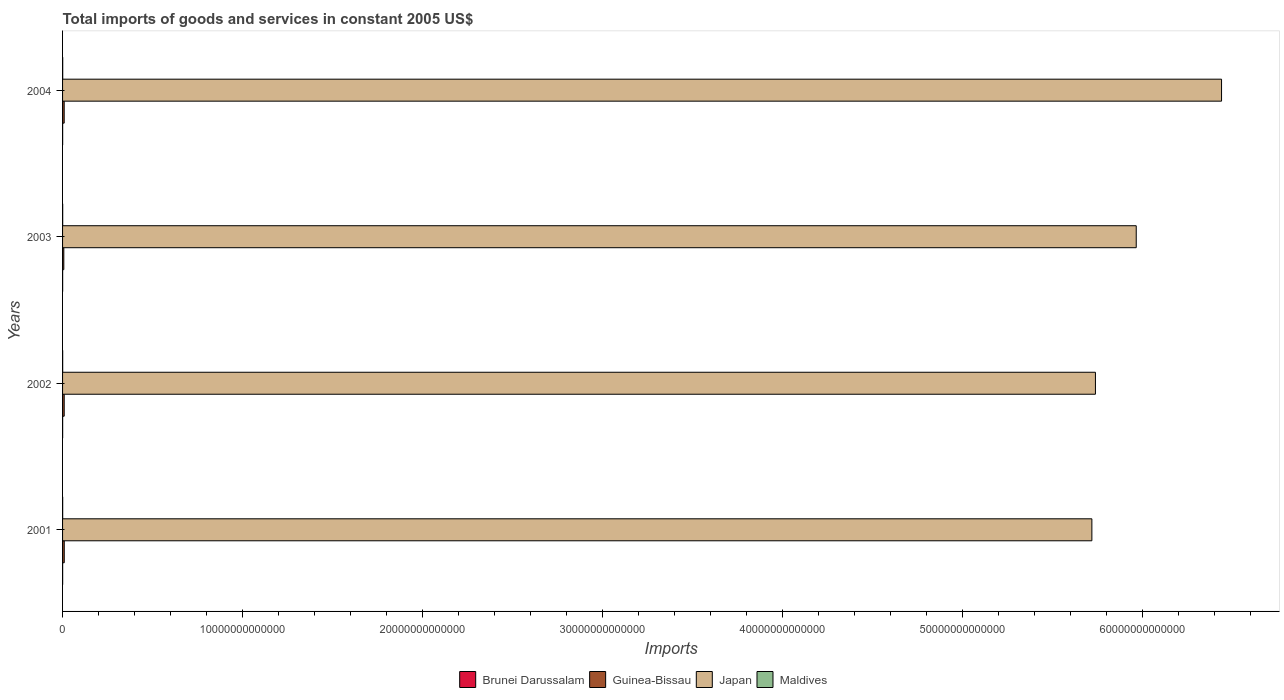Are the number of bars on each tick of the Y-axis equal?
Ensure brevity in your answer.  Yes. How many bars are there on the 1st tick from the top?
Provide a succinct answer. 4. What is the total imports of goods and services in Brunei Darussalam in 2002?
Provide a short and direct response. 4.33e+09. Across all years, what is the maximum total imports of goods and services in Guinea-Bissau?
Make the answer very short. 9.33e+1. Across all years, what is the minimum total imports of goods and services in Japan?
Your answer should be compact. 5.72e+13. In which year was the total imports of goods and services in Brunei Darussalam maximum?
Provide a short and direct response. 2002. In which year was the total imports of goods and services in Japan minimum?
Offer a very short reply. 2001. What is the total total imports of goods and services in Maldives in the graph?
Offer a very short reply. 2.55e+1. What is the difference between the total imports of goods and services in Japan in 2001 and that in 2003?
Offer a very short reply. -2.46e+12. What is the difference between the total imports of goods and services in Maldives in 2001 and the total imports of goods and services in Japan in 2002?
Your answer should be compact. -5.74e+13. What is the average total imports of goods and services in Guinea-Bissau per year?
Your answer should be compact. 8.58e+1. In the year 2003, what is the difference between the total imports of goods and services in Guinea-Bissau and total imports of goods and services in Japan?
Your answer should be very brief. -5.96e+13. In how many years, is the total imports of goods and services in Guinea-Bissau greater than 2000000000000 US$?
Offer a very short reply. 0. What is the ratio of the total imports of goods and services in Maldives in 2001 to that in 2003?
Give a very brief answer. 0.87. Is the total imports of goods and services in Maldives in 2001 less than that in 2002?
Your answer should be compact. Yes. Is the difference between the total imports of goods and services in Guinea-Bissau in 2002 and 2003 greater than the difference between the total imports of goods and services in Japan in 2002 and 2003?
Make the answer very short. Yes. What is the difference between the highest and the second highest total imports of goods and services in Japan?
Your answer should be compact. 4.74e+12. What is the difference between the highest and the lowest total imports of goods and services in Brunei Darussalam?
Offer a terse response. 5.10e+08. Is the sum of the total imports of goods and services in Brunei Darussalam in 2001 and 2004 greater than the maximum total imports of goods and services in Maldives across all years?
Give a very brief answer. No. What does the 3rd bar from the top in 2004 represents?
Keep it short and to the point. Guinea-Bissau. What does the 4th bar from the bottom in 2004 represents?
Make the answer very short. Maldives. Is it the case that in every year, the sum of the total imports of goods and services in Japan and total imports of goods and services in Guinea-Bissau is greater than the total imports of goods and services in Maldives?
Offer a terse response. Yes. How many bars are there?
Offer a very short reply. 16. Are all the bars in the graph horizontal?
Your answer should be compact. Yes. How many years are there in the graph?
Make the answer very short. 4. What is the difference between two consecutive major ticks on the X-axis?
Provide a succinct answer. 1.00e+13. Does the graph contain any zero values?
Provide a succinct answer. No. How are the legend labels stacked?
Give a very brief answer. Horizontal. What is the title of the graph?
Give a very brief answer. Total imports of goods and services in constant 2005 US$. Does "Cyprus" appear as one of the legend labels in the graph?
Your answer should be very brief. No. What is the label or title of the X-axis?
Ensure brevity in your answer.  Imports. What is the label or title of the Y-axis?
Offer a very short reply. Years. What is the Imports in Brunei Darussalam in 2001?
Your answer should be very brief. 3.82e+09. What is the Imports of Guinea-Bissau in 2001?
Ensure brevity in your answer.  9.33e+1. What is the Imports in Japan in 2001?
Ensure brevity in your answer.  5.72e+13. What is the Imports of Maldives in 2001?
Your answer should be very brief. 5.53e+09. What is the Imports of Brunei Darussalam in 2002?
Your answer should be compact. 4.33e+09. What is the Imports of Guinea-Bissau in 2002?
Offer a terse response. 9.06e+1. What is the Imports in Japan in 2002?
Ensure brevity in your answer.  5.74e+13. What is the Imports in Maldives in 2002?
Provide a short and direct response. 5.57e+09. What is the Imports in Brunei Darussalam in 2003?
Ensure brevity in your answer.  3.98e+09. What is the Imports of Guinea-Bissau in 2003?
Provide a succinct answer. 6.93e+1. What is the Imports of Japan in 2003?
Your answer should be compact. 5.96e+13. What is the Imports of Maldives in 2003?
Your response must be concise. 6.38e+09. What is the Imports of Brunei Darussalam in 2004?
Offer a very short reply. 3.86e+09. What is the Imports in Guinea-Bissau in 2004?
Your response must be concise. 9.00e+1. What is the Imports in Japan in 2004?
Make the answer very short. 6.44e+13. What is the Imports of Maldives in 2004?
Ensure brevity in your answer.  7.99e+09. Across all years, what is the maximum Imports of Brunei Darussalam?
Offer a very short reply. 4.33e+09. Across all years, what is the maximum Imports of Guinea-Bissau?
Keep it short and to the point. 9.33e+1. Across all years, what is the maximum Imports of Japan?
Your response must be concise. 6.44e+13. Across all years, what is the maximum Imports in Maldives?
Offer a very short reply. 7.99e+09. Across all years, what is the minimum Imports of Brunei Darussalam?
Provide a short and direct response. 3.82e+09. Across all years, what is the minimum Imports in Guinea-Bissau?
Make the answer very short. 6.93e+1. Across all years, what is the minimum Imports of Japan?
Offer a very short reply. 5.72e+13. Across all years, what is the minimum Imports of Maldives?
Give a very brief answer. 5.53e+09. What is the total Imports in Brunei Darussalam in the graph?
Offer a terse response. 1.60e+1. What is the total Imports in Guinea-Bissau in the graph?
Your response must be concise. 3.43e+11. What is the total Imports of Japan in the graph?
Provide a succinct answer. 2.39e+14. What is the total Imports in Maldives in the graph?
Keep it short and to the point. 2.55e+1. What is the difference between the Imports of Brunei Darussalam in 2001 and that in 2002?
Offer a very short reply. -5.10e+08. What is the difference between the Imports in Guinea-Bissau in 2001 and that in 2002?
Your answer should be compact. 2.73e+09. What is the difference between the Imports in Japan in 2001 and that in 2002?
Offer a terse response. -1.98e+11. What is the difference between the Imports in Maldives in 2001 and that in 2002?
Provide a succinct answer. -3.24e+07. What is the difference between the Imports in Brunei Darussalam in 2001 and that in 2003?
Provide a short and direct response. -1.60e+08. What is the difference between the Imports of Guinea-Bissau in 2001 and that in 2003?
Your answer should be compact. 2.40e+1. What is the difference between the Imports in Japan in 2001 and that in 2003?
Your answer should be very brief. -2.46e+12. What is the difference between the Imports of Maldives in 2001 and that in 2003?
Make the answer very short. -8.45e+08. What is the difference between the Imports of Brunei Darussalam in 2001 and that in 2004?
Make the answer very short. -3.53e+07. What is the difference between the Imports of Guinea-Bissau in 2001 and that in 2004?
Your response must be concise. 3.27e+09. What is the difference between the Imports of Japan in 2001 and that in 2004?
Ensure brevity in your answer.  -7.20e+12. What is the difference between the Imports of Maldives in 2001 and that in 2004?
Your answer should be compact. -2.45e+09. What is the difference between the Imports in Brunei Darussalam in 2002 and that in 2003?
Provide a succinct answer. 3.50e+08. What is the difference between the Imports of Guinea-Bissau in 2002 and that in 2003?
Your response must be concise. 2.13e+1. What is the difference between the Imports of Japan in 2002 and that in 2003?
Give a very brief answer. -2.27e+12. What is the difference between the Imports in Maldives in 2002 and that in 2003?
Offer a very short reply. -8.12e+08. What is the difference between the Imports in Brunei Darussalam in 2002 and that in 2004?
Give a very brief answer. 4.75e+08. What is the difference between the Imports in Guinea-Bissau in 2002 and that in 2004?
Your response must be concise. 5.35e+08. What is the difference between the Imports in Japan in 2002 and that in 2004?
Give a very brief answer. -7.01e+12. What is the difference between the Imports in Maldives in 2002 and that in 2004?
Provide a succinct answer. -2.42e+09. What is the difference between the Imports of Brunei Darussalam in 2003 and that in 2004?
Your response must be concise. 1.25e+08. What is the difference between the Imports of Guinea-Bissau in 2003 and that in 2004?
Make the answer very short. -2.08e+1. What is the difference between the Imports in Japan in 2003 and that in 2004?
Provide a succinct answer. -4.74e+12. What is the difference between the Imports in Maldives in 2003 and that in 2004?
Your response must be concise. -1.61e+09. What is the difference between the Imports of Brunei Darussalam in 2001 and the Imports of Guinea-Bissau in 2002?
Give a very brief answer. -8.67e+1. What is the difference between the Imports of Brunei Darussalam in 2001 and the Imports of Japan in 2002?
Keep it short and to the point. -5.74e+13. What is the difference between the Imports of Brunei Darussalam in 2001 and the Imports of Maldives in 2002?
Ensure brevity in your answer.  -1.74e+09. What is the difference between the Imports in Guinea-Bissau in 2001 and the Imports in Japan in 2002?
Give a very brief answer. -5.73e+13. What is the difference between the Imports of Guinea-Bissau in 2001 and the Imports of Maldives in 2002?
Provide a succinct answer. 8.77e+1. What is the difference between the Imports of Japan in 2001 and the Imports of Maldives in 2002?
Provide a succinct answer. 5.72e+13. What is the difference between the Imports in Brunei Darussalam in 2001 and the Imports in Guinea-Bissau in 2003?
Your answer should be compact. -6.54e+1. What is the difference between the Imports of Brunei Darussalam in 2001 and the Imports of Japan in 2003?
Your answer should be compact. -5.96e+13. What is the difference between the Imports of Brunei Darussalam in 2001 and the Imports of Maldives in 2003?
Make the answer very short. -2.56e+09. What is the difference between the Imports of Guinea-Bissau in 2001 and the Imports of Japan in 2003?
Your answer should be compact. -5.96e+13. What is the difference between the Imports of Guinea-Bissau in 2001 and the Imports of Maldives in 2003?
Give a very brief answer. 8.69e+1. What is the difference between the Imports in Japan in 2001 and the Imports in Maldives in 2003?
Your response must be concise. 5.72e+13. What is the difference between the Imports in Brunei Darussalam in 2001 and the Imports in Guinea-Bissau in 2004?
Your response must be concise. -8.62e+1. What is the difference between the Imports of Brunei Darussalam in 2001 and the Imports of Japan in 2004?
Ensure brevity in your answer.  -6.44e+13. What is the difference between the Imports of Brunei Darussalam in 2001 and the Imports of Maldives in 2004?
Offer a very short reply. -4.16e+09. What is the difference between the Imports of Guinea-Bissau in 2001 and the Imports of Japan in 2004?
Your answer should be compact. -6.43e+13. What is the difference between the Imports of Guinea-Bissau in 2001 and the Imports of Maldives in 2004?
Make the answer very short. 8.53e+1. What is the difference between the Imports in Japan in 2001 and the Imports in Maldives in 2004?
Your answer should be compact. 5.72e+13. What is the difference between the Imports in Brunei Darussalam in 2002 and the Imports in Guinea-Bissau in 2003?
Provide a succinct answer. -6.49e+1. What is the difference between the Imports in Brunei Darussalam in 2002 and the Imports in Japan in 2003?
Provide a short and direct response. -5.96e+13. What is the difference between the Imports in Brunei Darussalam in 2002 and the Imports in Maldives in 2003?
Your answer should be very brief. -2.05e+09. What is the difference between the Imports of Guinea-Bissau in 2002 and the Imports of Japan in 2003?
Keep it short and to the point. -5.96e+13. What is the difference between the Imports of Guinea-Bissau in 2002 and the Imports of Maldives in 2003?
Keep it short and to the point. 8.42e+1. What is the difference between the Imports of Japan in 2002 and the Imports of Maldives in 2003?
Provide a succinct answer. 5.74e+13. What is the difference between the Imports of Brunei Darussalam in 2002 and the Imports of Guinea-Bissau in 2004?
Your answer should be compact. -8.57e+1. What is the difference between the Imports of Brunei Darussalam in 2002 and the Imports of Japan in 2004?
Your response must be concise. -6.44e+13. What is the difference between the Imports of Brunei Darussalam in 2002 and the Imports of Maldives in 2004?
Offer a very short reply. -3.65e+09. What is the difference between the Imports of Guinea-Bissau in 2002 and the Imports of Japan in 2004?
Ensure brevity in your answer.  -6.43e+13. What is the difference between the Imports of Guinea-Bissau in 2002 and the Imports of Maldives in 2004?
Give a very brief answer. 8.26e+1. What is the difference between the Imports of Japan in 2002 and the Imports of Maldives in 2004?
Offer a terse response. 5.74e+13. What is the difference between the Imports in Brunei Darussalam in 2003 and the Imports in Guinea-Bissau in 2004?
Make the answer very short. -8.60e+1. What is the difference between the Imports of Brunei Darussalam in 2003 and the Imports of Japan in 2004?
Give a very brief answer. -6.44e+13. What is the difference between the Imports in Brunei Darussalam in 2003 and the Imports in Maldives in 2004?
Offer a terse response. -4.00e+09. What is the difference between the Imports in Guinea-Bissau in 2003 and the Imports in Japan in 2004?
Provide a succinct answer. -6.43e+13. What is the difference between the Imports in Guinea-Bissau in 2003 and the Imports in Maldives in 2004?
Offer a terse response. 6.13e+1. What is the difference between the Imports in Japan in 2003 and the Imports in Maldives in 2004?
Offer a terse response. 5.96e+13. What is the average Imports of Brunei Darussalam per year?
Make the answer very short. 4.00e+09. What is the average Imports in Guinea-Bissau per year?
Your answer should be compact. 8.58e+1. What is the average Imports in Japan per year?
Ensure brevity in your answer.  5.96e+13. What is the average Imports of Maldives per year?
Your response must be concise. 6.37e+09. In the year 2001, what is the difference between the Imports in Brunei Darussalam and Imports in Guinea-Bissau?
Keep it short and to the point. -8.95e+1. In the year 2001, what is the difference between the Imports of Brunei Darussalam and Imports of Japan?
Provide a short and direct response. -5.72e+13. In the year 2001, what is the difference between the Imports of Brunei Darussalam and Imports of Maldives?
Offer a very short reply. -1.71e+09. In the year 2001, what is the difference between the Imports in Guinea-Bissau and Imports in Japan?
Your response must be concise. -5.71e+13. In the year 2001, what is the difference between the Imports of Guinea-Bissau and Imports of Maldives?
Offer a very short reply. 8.77e+1. In the year 2001, what is the difference between the Imports in Japan and Imports in Maldives?
Make the answer very short. 5.72e+13. In the year 2002, what is the difference between the Imports of Brunei Darussalam and Imports of Guinea-Bissau?
Your response must be concise. -8.62e+1. In the year 2002, what is the difference between the Imports of Brunei Darussalam and Imports of Japan?
Provide a short and direct response. -5.74e+13. In the year 2002, what is the difference between the Imports of Brunei Darussalam and Imports of Maldives?
Provide a succinct answer. -1.23e+09. In the year 2002, what is the difference between the Imports of Guinea-Bissau and Imports of Japan?
Make the answer very short. -5.73e+13. In the year 2002, what is the difference between the Imports in Guinea-Bissau and Imports in Maldives?
Offer a very short reply. 8.50e+1. In the year 2002, what is the difference between the Imports in Japan and Imports in Maldives?
Your answer should be compact. 5.74e+13. In the year 2003, what is the difference between the Imports in Brunei Darussalam and Imports in Guinea-Bissau?
Make the answer very short. -6.53e+1. In the year 2003, what is the difference between the Imports of Brunei Darussalam and Imports of Japan?
Offer a very short reply. -5.96e+13. In the year 2003, what is the difference between the Imports of Brunei Darussalam and Imports of Maldives?
Your answer should be very brief. -2.39e+09. In the year 2003, what is the difference between the Imports of Guinea-Bissau and Imports of Japan?
Your answer should be compact. -5.96e+13. In the year 2003, what is the difference between the Imports in Guinea-Bissau and Imports in Maldives?
Offer a terse response. 6.29e+1. In the year 2003, what is the difference between the Imports of Japan and Imports of Maldives?
Keep it short and to the point. 5.96e+13. In the year 2004, what is the difference between the Imports in Brunei Darussalam and Imports in Guinea-Bissau?
Keep it short and to the point. -8.62e+1. In the year 2004, what is the difference between the Imports in Brunei Darussalam and Imports in Japan?
Your answer should be very brief. -6.44e+13. In the year 2004, what is the difference between the Imports of Brunei Darussalam and Imports of Maldives?
Keep it short and to the point. -4.13e+09. In the year 2004, what is the difference between the Imports in Guinea-Bissau and Imports in Japan?
Your answer should be compact. -6.43e+13. In the year 2004, what is the difference between the Imports in Guinea-Bissau and Imports in Maldives?
Your answer should be very brief. 8.20e+1. In the year 2004, what is the difference between the Imports of Japan and Imports of Maldives?
Your answer should be compact. 6.44e+13. What is the ratio of the Imports of Brunei Darussalam in 2001 to that in 2002?
Your response must be concise. 0.88. What is the ratio of the Imports in Guinea-Bissau in 2001 to that in 2002?
Your response must be concise. 1.03. What is the ratio of the Imports of Brunei Darussalam in 2001 to that in 2003?
Keep it short and to the point. 0.96. What is the ratio of the Imports in Guinea-Bissau in 2001 to that in 2003?
Your response must be concise. 1.35. What is the ratio of the Imports in Japan in 2001 to that in 2003?
Your answer should be compact. 0.96. What is the ratio of the Imports of Maldives in 2001 to that in 2003?
Ensure brevity in your answer.  0.87. What is the ratio of the Imports in Brunei Darussalam in 2001 to that in 2004?
Ensure brevity in your answer.  0.99. What is the ratio of the Imports in Guinea-Bissau in 2001 to that in 2004?
Your answer should be compact. 1.04. What is the ratio of the Imports of Japan in 2001 to that in 2004?
Ensure brevity in your answer.  0.89. What is the ratio of the Imports of Maldives in 2001 to that in 2004?
Keep it short and to the point. 0.69. What is the ratio of the Imports in Brunei Darussalam in 2002 to that in 2003?
Offer a terse response. 1.09. What is the ratio of the Imports of Guinea-Bissau in 2002 to that in 2003?
Provide a short and direct response. 1.31. What is the ratio of the Imports in Japan in 2002 to that in 2003?
Give a very brief answer. 0.96. What is the ratio of the Imports of Maldives in 2002 to that in 2003?
Provide a short and direct response. 0.87. What is the ratio of the Imports in Brunei Darussalam in 2002 to that in 2004?
Ensure brevity in your answer.  1.12. What is the ratio of the Imports in Guinea-Bissau in 2002 to that in 2004?
Make the answer very short. 1.01. What is the ratio of the Imports in Japan in 2002 to that in 2004?
Your answer should be compact. 0.89. What is the ratio of the Imports in Maldives in 2002 to that in 2004?
Make the answer very short. 0.7. What is the ratio of the Imports of Brunei Darussalam in 2003 to that in 2004?
Give a very brief answer. 1.03. What is the ratio of the Imports in Guinea-Bissau in 2003 to that in 2004?
Keep it short and to the point. 0.77. What is the ratio of the Imports in Japan in 2003 to that in 2004?
Make the answer very short. 0.93. What is the ratio of the Imports in Maldives in 2003 to that in 2004?
Your answer should be compact. 0.8. What is the difference between the highest and the second highest Imports in Brunei Darussalam?
Give a very brief answer. 3.50e+08. What is the difference between the highest and the second highest Imports of Guinea-Bissau?
Ensure brevity in your answer.  2.73e+09. What is the difference between the highest and the second highest Imports of Japan?
Provide a succinct answer. 4.74e+12. What is the difference between the highest and the second highest Imports in Maldives?
Give a very brief answer. 1.61e+09. What is the difference between the highest and the lowest Imports of Brunei Darussalam?
Make the answer very short. 5.10e+08. What is the difference between the highest and the lowest Imports in Guinea-Bissau?
Provide a succinct answer. 2.40e+1. What is the difference between the highest and the lowest Imports of Japan?
Give a very brief answer. 7.20e+12. What is the difference between the highest and the lowest Imports in Maldives?
Ensure brevity in your answer.  2.45e+09. 